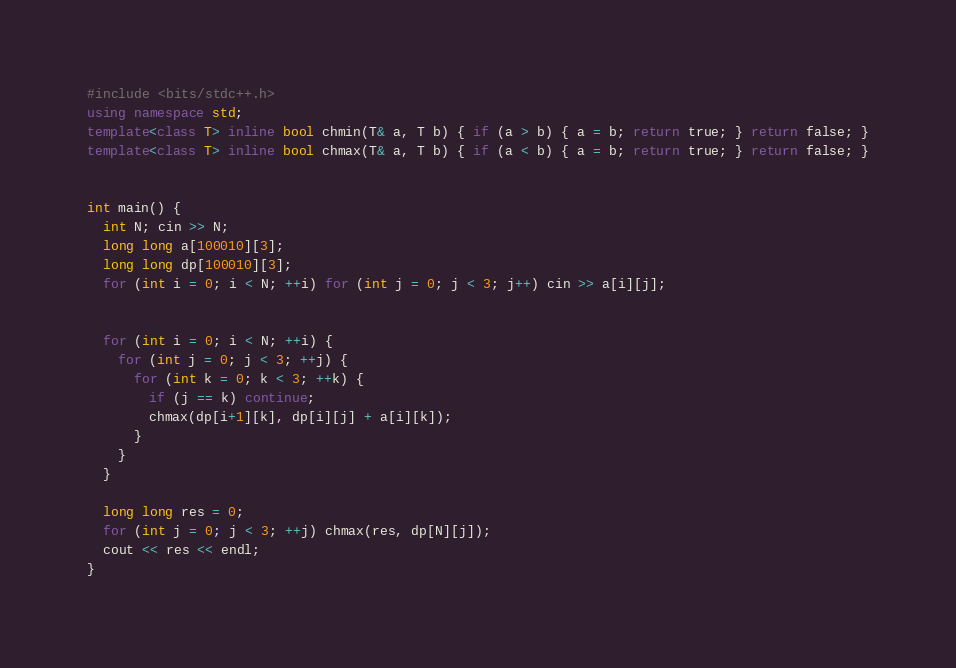<code> <loc_0><loc_0><loc_500><loc_500><_C++_>#include <bits/stdc++.h>
using namespace std;
template<class T> inline bool chmin(T& a, T b) { if (a > b) { a = b; return true; } return false; }
template<class T> inline bool chmax(T& a, T b) { if (a < b) { a = b; return true; } return false; }


int main() {
  int N; cin >> N;
  long long a[100010][3];
  long long dp[100010][3];
  for (int i = 0; i < N; ++i) for (int j = 0; j < 3; j++) cin >> a[i][j];


  for (int i = 0; i < N; ++i) {
    for (int j = 0; j < 3; ++j) {
      for (int k = 0; k < 3; ++k) {
        if (j == k) continue;
        chmax(dp[i+1][k], dp[i][j] + a[i][k]);
      }
    }
  }
  
  long long res = 0;
  for (int j = 0; j < 3; ++j) chmax(res, dp[N][j]);
  cout << res << endl;
}</code> 